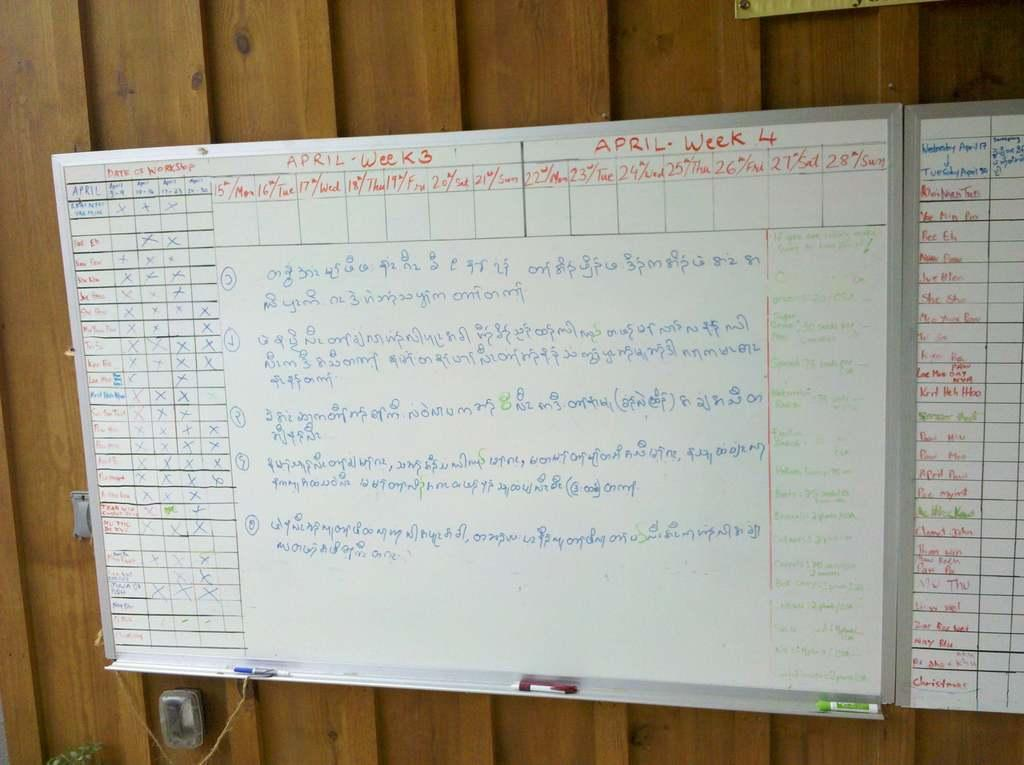<image>
Create a compact narrative representing the image presented. A whiteboard contains scheduling information for two weeks in April. 